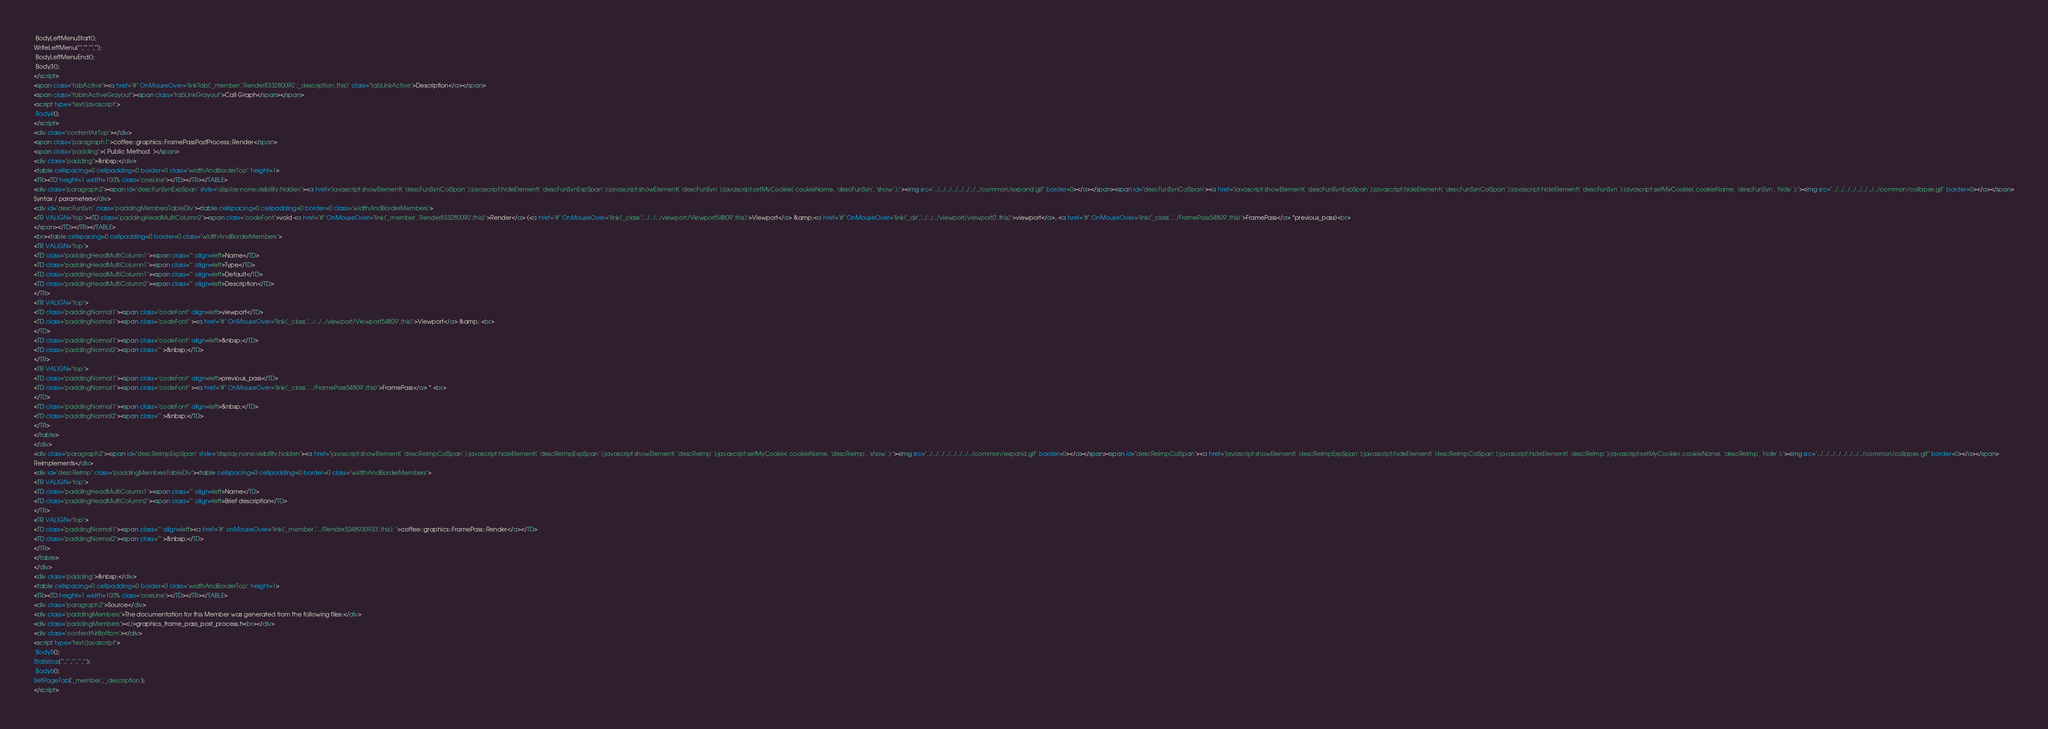<code> <loc_0><loc_0><loc_500><loc_500><_HTML_> BodyLeftMenuStart();
WriteLeftMenu("","","","");
 BodyLeftMenuEnd();
 Body3();
</script>
<span class="tabActive"><a href="#" OnMouseOver="linkTab('_member','Render833280090','_description',this)" class="tabLinkActive">Description</a></span>
<span class="tabInActiveGrayout"><span class="tabLinkGrayout">Call Graph</span></span>
<script type="text/javascript">
 Body4();
</script>
<div class="contentAirTop"></div>
<span class="paragraph1">coffee::graphics::FramePassPostProcess::Render</span>
<span class="padding">( Public Method  )</span>
<div class="padding">&nbsp;</div>
<table cellspacing=0 cellpadding=0 border=0 class="widthAndBorderTop" height=1>
<TR><TD height=1 width=100% class="oneLine"></TD></TR></TABLE>
<div class="paragraph2"><span id="descFunSynExpSpan" style="display:none;visibility:hidden"><a href="javascript:showElement( 'descFunSynColSpan' );javascript:hideElement( 'descFunSynExpSpan' );javascript:showElement( 'descFunSyn' );javascript:setMyCookie( cookieName, 'descFunSyn', 'show' );"><img src="../../../../../../../../common/expand.gif" border=0></a></span><span id="descFunSynColSpan"><a href="javascript:showElement( 'descFunSynExpSpan' );javascript:hideElement( 'descFunSynColSpan' );javascript:hideElement( 'descFunSyn' );javascript:setMyCookie( cookieName, 'descFunSyn', 'hide' );"><img src="../../../../../../../../common/collapse.gif" border=0></a></span>
Syntax / parameters</div>
<div id="descFunSyn" class="paddingMembersTableDiv"><table cellspacing=0 cellpadding=0 border=0 class="widthAndBorderMembers">
<TR VALIGN="top"><TD class="paddingHeadMultiColumn2"><span class="codeFont">void <a href="#" OnMouseOver="link('_member','Render833280090',this)">Render</a> (<a href="#" OnMouseOver="link('_class','../../../viewport/Viewport54809',this)">Viewport</a> &amp;<a href="#" OnMouseOver="link('_dir','../../../viewport/viewport0',this)">viewport</a>, <a href="#" OnMouseOver="link('_class','../FramePass54809',this)">FramePass</a> *previous_pass)<br>
</span></TD></TR></TABLE>
<br><table cellspacing=0 cellpadding=0 border=0 class="widthAndBorderMembers">
<TR VALIGN="top">
<TD class="paddingHeadMultiColumn1"><span class="" align=left>Name</TD>
<TD class="paddingHeadMultiColumn1"><span class="" align=left>Type</TD>
<TD class="paddingHeadMultiColumn1"><span class="" align=left>Default</TD>
<TD class="paddingHeadMultiColumn2"><span class="" align=left>Description</TD>
</TR>
<TR VALIGN="top">
<TD class="paddingNormal1"><span class="codeFont" align=left>viewport</TD>
<TD class="paddingNormal1"><span class="codeFont" ><a href="#" OnMouseOver="link('_class','../../../viewport/Viewport54809',this)">Viewport</a> &amp; <br>
</TD>
<TD class="paddingNormal1"><span class="codeFont" align=left>&nbsp;</TD>
<TD class="paddingNormal2"><span class="" >&nbsp;</TD>
</TR>
<TR VALIGN="top">
<TD class="paddingNormal1"><span class="codeFont" align=left>previous_pass</TD>
<TD class="paddingNormal1"><span class="codeFont" ><a href="#" OnMouseOver="link('_class','../FramePass54809',this)">FramePass</a> * <br>
</TD>
<TD class="paddingNormal1"><span class="codeFont" align=left>&nbsp;</TD>
<TD class="paddingNormal2"><span class="" >&nbsp;</TD>
</TR>
</table>
</div>
<div class="paragraph2"><span id="descReImpExpSpan" style="display:none;visibility:hidden"><a href="javascript:showElement( 'descReImpColSpan' );javascript:hideElement( 'descReImpExpSpan' );javascript:showElement( 'descReImp' );javascript:setMyCookie( cookieName, 'descReImp', 'show' );"><img src="../../../../../../../../common/expand.gif" border=0></a></span><span id="descReImpColSpan"><a href="javascript:showElement( 'descReImpExpSpan' );javascript:hideElement( 'descReImpColSpan' );javascript:hideElement( 'descReImp' );javascript:setMyCookie( cookieName, 'descReImp', 'hide' );"><img src="../../../../../../../../common/collapse.gif" border=0></a></span>
Reimplements</div>
<div id="descReImp" class="paddingMembersTableDiv"><table cellspacing=0 cellpadding=0 border=0 class="widthAndBorderMembers">
<TR VALIGN="top">
<TD class="paddingHeadMultiColumn1"><span class="" align=left>Name</TD>
<TD class="paddingHeadMultiColumn2"><span class="" align=left>Brief description</TD>
</TR>
<TR VALIGN="top">
<TD class="paddingNormal1"><span class="" align=left><a href="#" onMouseOver="link('_member','../Render3248930933',this); ">coffee::graphics::FramePass::Render</a></TD>
<TD class="paddingNormal2"><span class="" >&nbsp;</TD>
</TR>
</table>
</div>
<div class="padding">&nbsp;</div>
<table cellspacing=0 cellpadding=0 border=0 class="widthAndBorderTop" height=1>
<TR><TD height=1 width=100% class="oneLine"></TD></TR></TABLE>
<div class="paragraph2">Source</div>
<div class="paddingMembers">The documentation for this Member was generated from the following files:</div>
<div class="paddingMembers"><LI>graphics_frame_pass_post_process.h<br></div>
<div class="contentAirBottom"></div>
<script type="text/javascript">
 Body5();
Statistics("","","","","");
 Body6();
SetPageTab('_member','_description');
</script>
</code> 